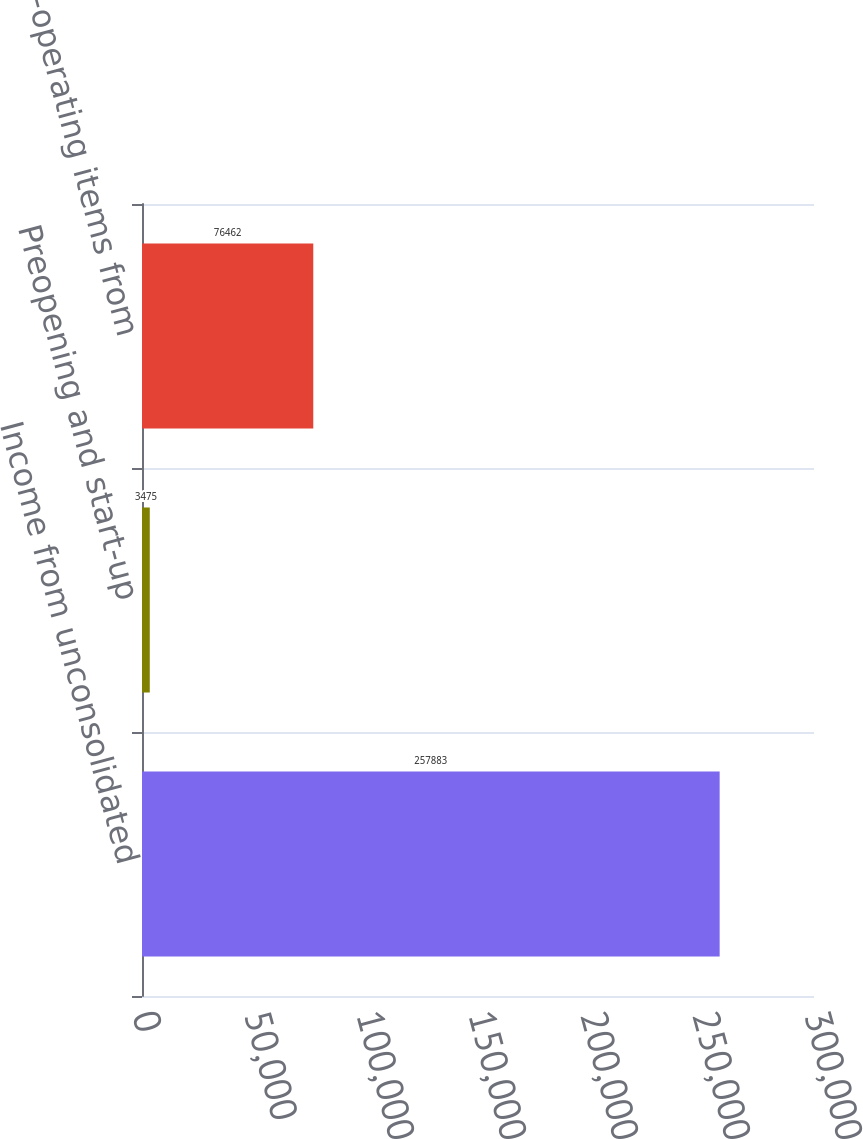Convert chart to OTSL. <chart><loc_0><loc_0><loc_500><loc_500><bar_chart><fcel>Income from unconsolidated<fcel>Preopening and start-up<fcel>Non-operating items from<nl><fcel>257883<fcel>3475<fcel>76462<nl></chart> 